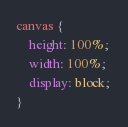Convert code to text. <code><loc_0><loc_0><loc_500><loc_500><_CSS_>canvas { 
    height: 100%; 
    width: 100%; 
    display: block;
}</code> 